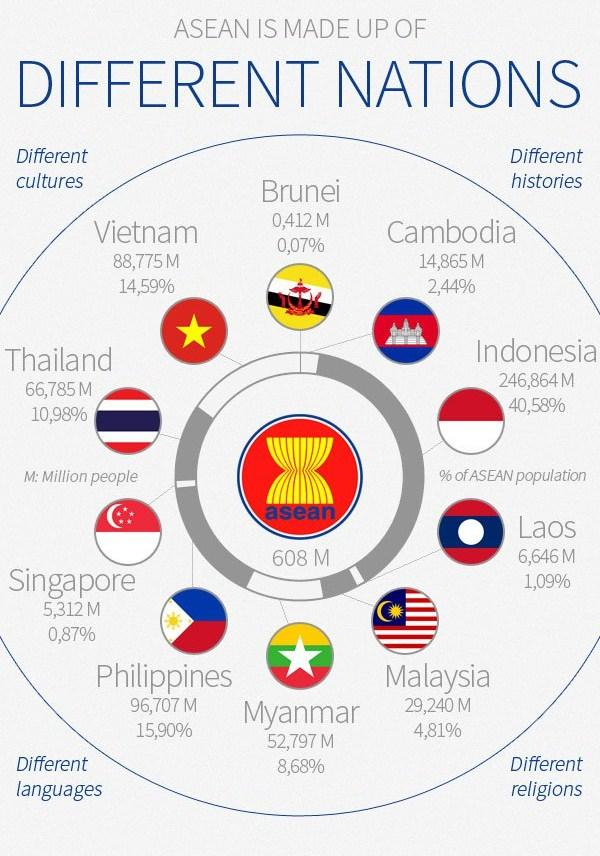Draw attention to some important aspects in this diagram. The total population of the ASEAN countries is approximately 608 million. Ten countries are members of the Association of Southeast Asian Nations (ASEAN). The population percentage of Malaysia is 4.81%. The population of Vietnam is approximately 95 million, as of 2021. Indonesia has the highest population among the ASEAN countries in millions. 